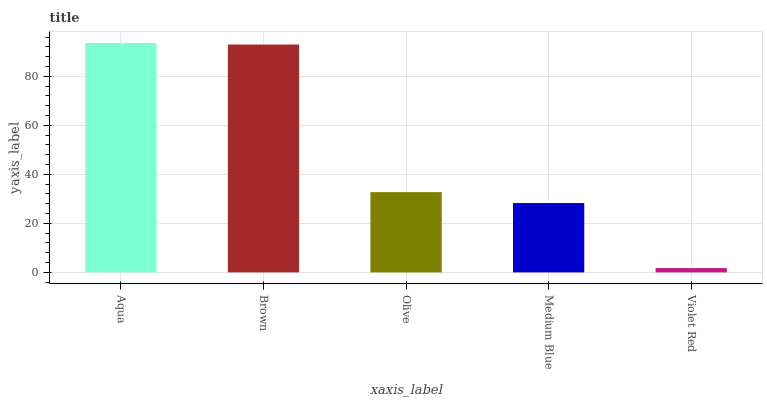Is Violet Red the minimum?
Answer yes or no. Yes. Is Aqua the maximum?
Answer yes or no. Yes. Is Brown the minimum?
Answer yes or no. No. Is Brown the maximum?
Answer yes or no. No. Is Aqua greater than Brown?
Answer yes or no. Yes. Is Brown less than Aqua?
Answer yes or no. Yes. Is Brown greater than Aqua?
Answer yes or no. No. Is Aqua less than Brown?
Answer yes or no. No. Is Olive the high median?
Answer yes or no. Yes. Is Olive the low median?
Answer yes or no. Yes. Is Brown the high median?
Answer yes or no. No. Is Medium Blue the low median?
Answer yes or no. No. 